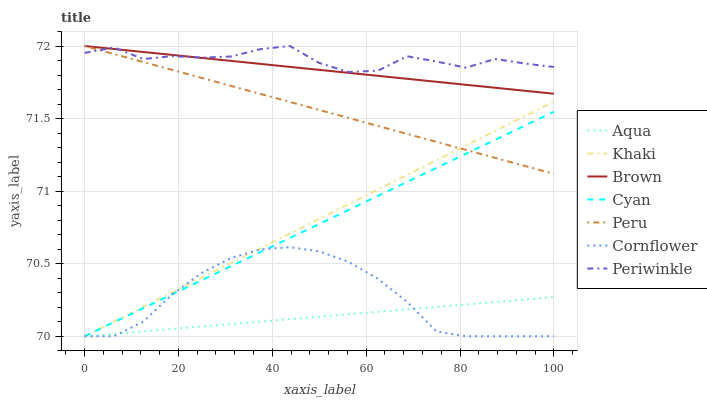Does Aqua have the minimum area under the curve?
Answer yes or no. Yes. Does Periwinkle have the maximum area under the curve?
Answer yes or no. Yes. Does Khaki have the minimum area under the curve?
Answer yes or no. No. Does Khaki have the maximum area under the curve?
Answer yes or no. No. Is Brown the smoothest?
Answer yes or no. Yes. Is Periwinkle the roughest?
Answer yes or no. Yes. Is Khaki the smoothest?
Answer yes or no. No. Is Khaki the roughest?
Answer yes or no. No. Does Khaki have the lowest value?
Answer yes or no. Yes. Does Periwinkle have the lowest value?
Answer yes or no. No. Does Peru have the highest value?
Answer yes or no. Yes. Does Khaki have the highest value?
Answer yes or no. No. Is Cyan less than Periwinkle?
Answer yes or no. Yes. Is Brown greater than Aqua?
Answer yes or no. Yes. Does Aqua intersect Cyan?
Answer yes or no. Yes. Is Aqua less than Cyan?
Answer yes or no. No. Is Aqua greater than Cyan?
Answer yes or no. No. Does Cyan intersect Periwinkle?
Answer yes or no. No. 